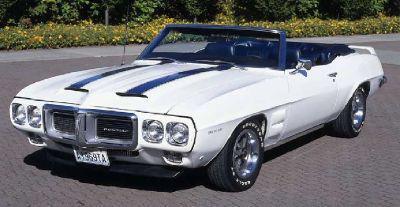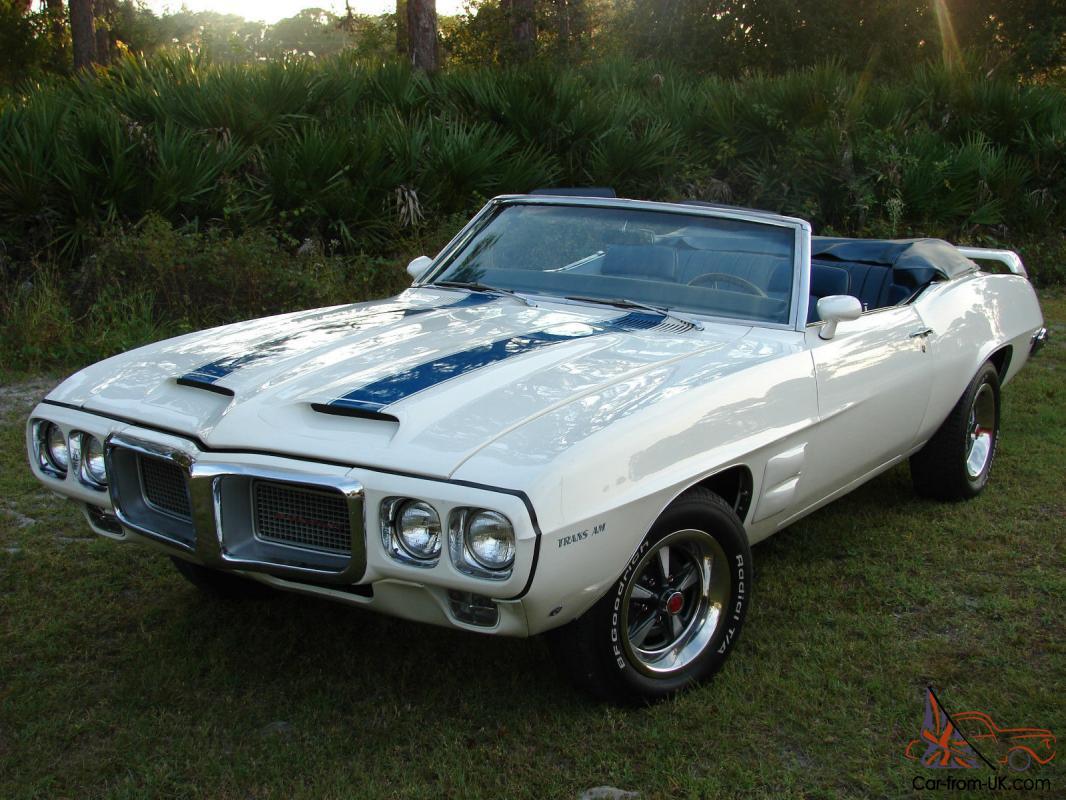The first image is the image on the left, the second image is the image on the right. For the images displayed, is the sentence "Two cars are facing left." factually correct? Answer yes or no. Yes. 